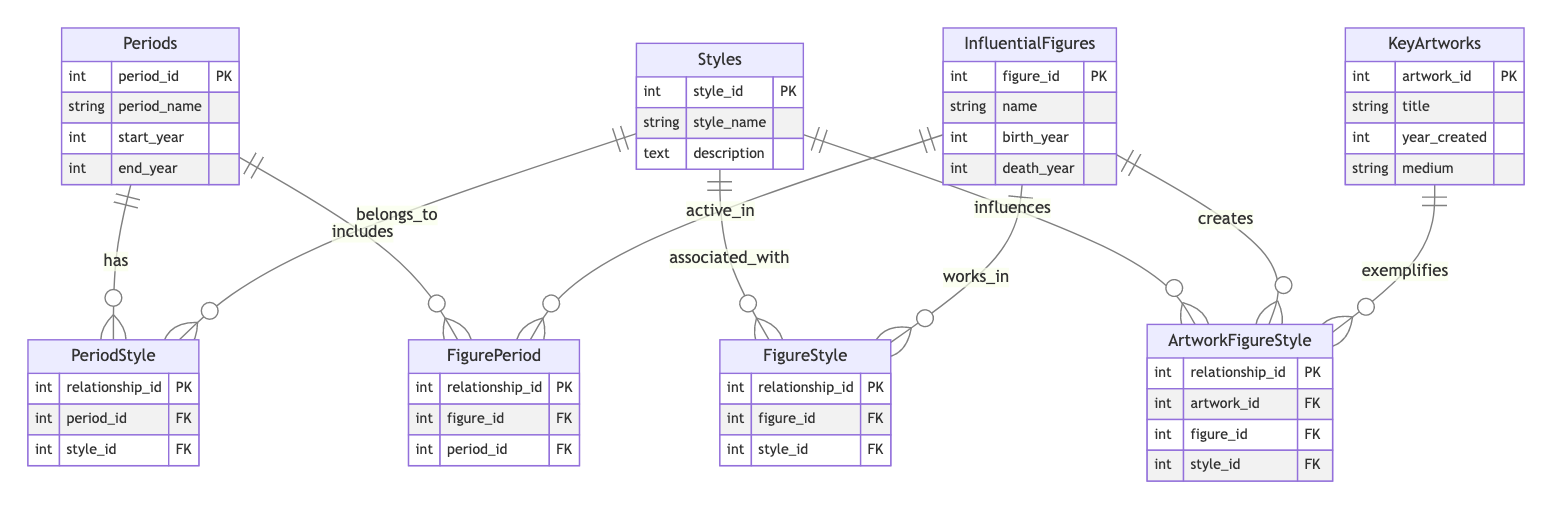What are the entities represented in the diagram? The diagram includes four entities: Periods, Styles, Influential Figures, and Key Artworks. These are the main categories outlined in the diagram structure.
Answer: Periods, Styles, Influential Figures, Key Artworks How many attributes does the Key Artworks entity have? The Key Artworks entity has four attributes: artwork_id, title, year_created, and medium. Counting these gives a total of four attributes.
Answer: Four What relationship exists between Periods and Styles? The relationship between Periods and Styles is called "PeriodStyle", indicating that periods can have associated styles. This is shown by the lines connecting the two entities.
Answer: PeriodStyle Which entity is linked to the FigureStyle relationship? The FigureStyle relationship connects the Influential Figures entity with the Styles entity, indicating that figures can work within specific artistic styles.
Answer: Influential Figures How many total relationships are present in the diagram? There are four relationships depicted in the diagram: PeriodStyle, FigurePeriod, FigureStyle, and ArtworkFigureStyle. Counting these gives a total of four relationships.
Answer: Four Which attribute is a primary key in the Influential Figures entity? The primary key in the Influential Figures entity is figure_id. This is specified in the diagram as the unique identifier for each figure.
Answer: figure_id What is the nature of the relationship between Influential Figures and Key Artworks? The relationship between Influential Figures and Key Artworks is defined by ArtworkFigureStyle, meaning that influential figures create key artworks and are linked through this relationship.
Answer: ArtworkFigureStyle Which entities are related via the FigurePeriod relationship? The FigurePeriod relationship connects Influential Figures and Periods, indicating that figures are active in specific periods of art history. This shows a direct relationship between these two entities.
Answer: InfluentialFigures and Periods How many styles can a single period be associated with? A single period can be associated with multiple styles as indicated by the "has" relationship in the PeriodStyle section, which allows for many-to-many relationships between periods and styles.
Answer: Many 